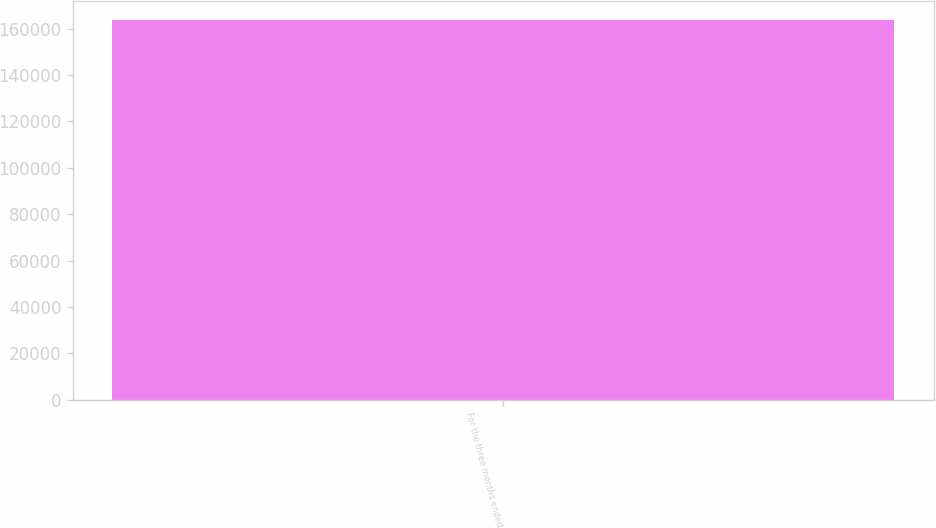<chart> <loc_0><loc_0><loc_500><loc_500><bar_chart><fcel>For the three months ended<nl><fcel>163857<nl></chart> 